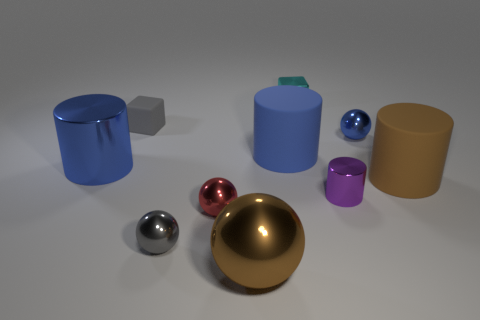Which object stands out the most in this collection and why? The large gold sphere stands out prominently due to its size and its shiny, reflective surface which draws the eye amongst the collection of more matte and smaller objects. 